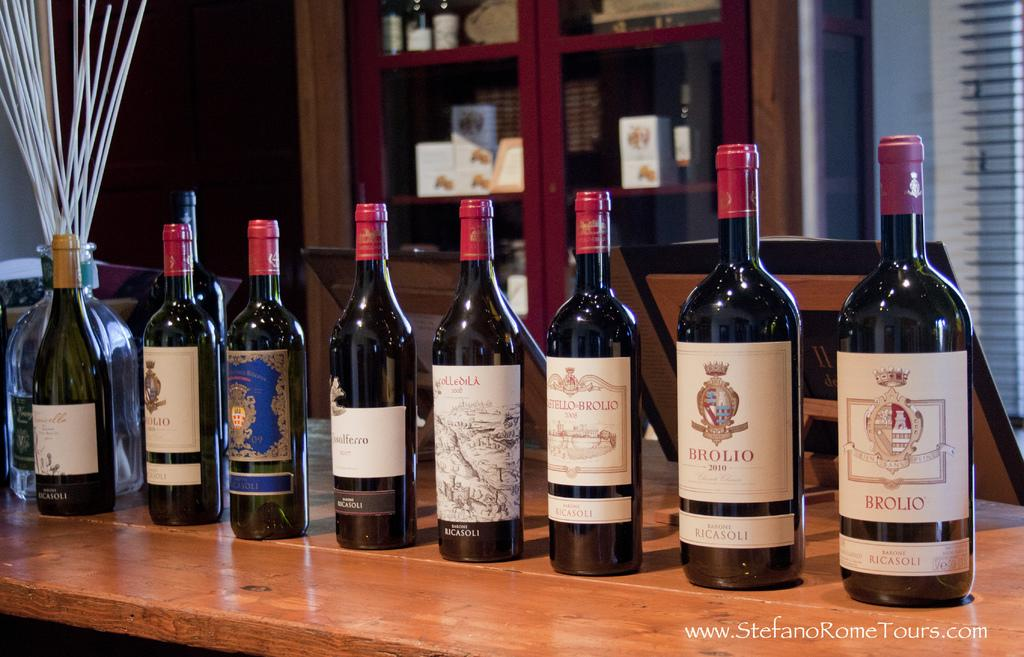<image>
Create a compact narrative representing the image presented. A bottle of Brolio is the first bottle in a line. 